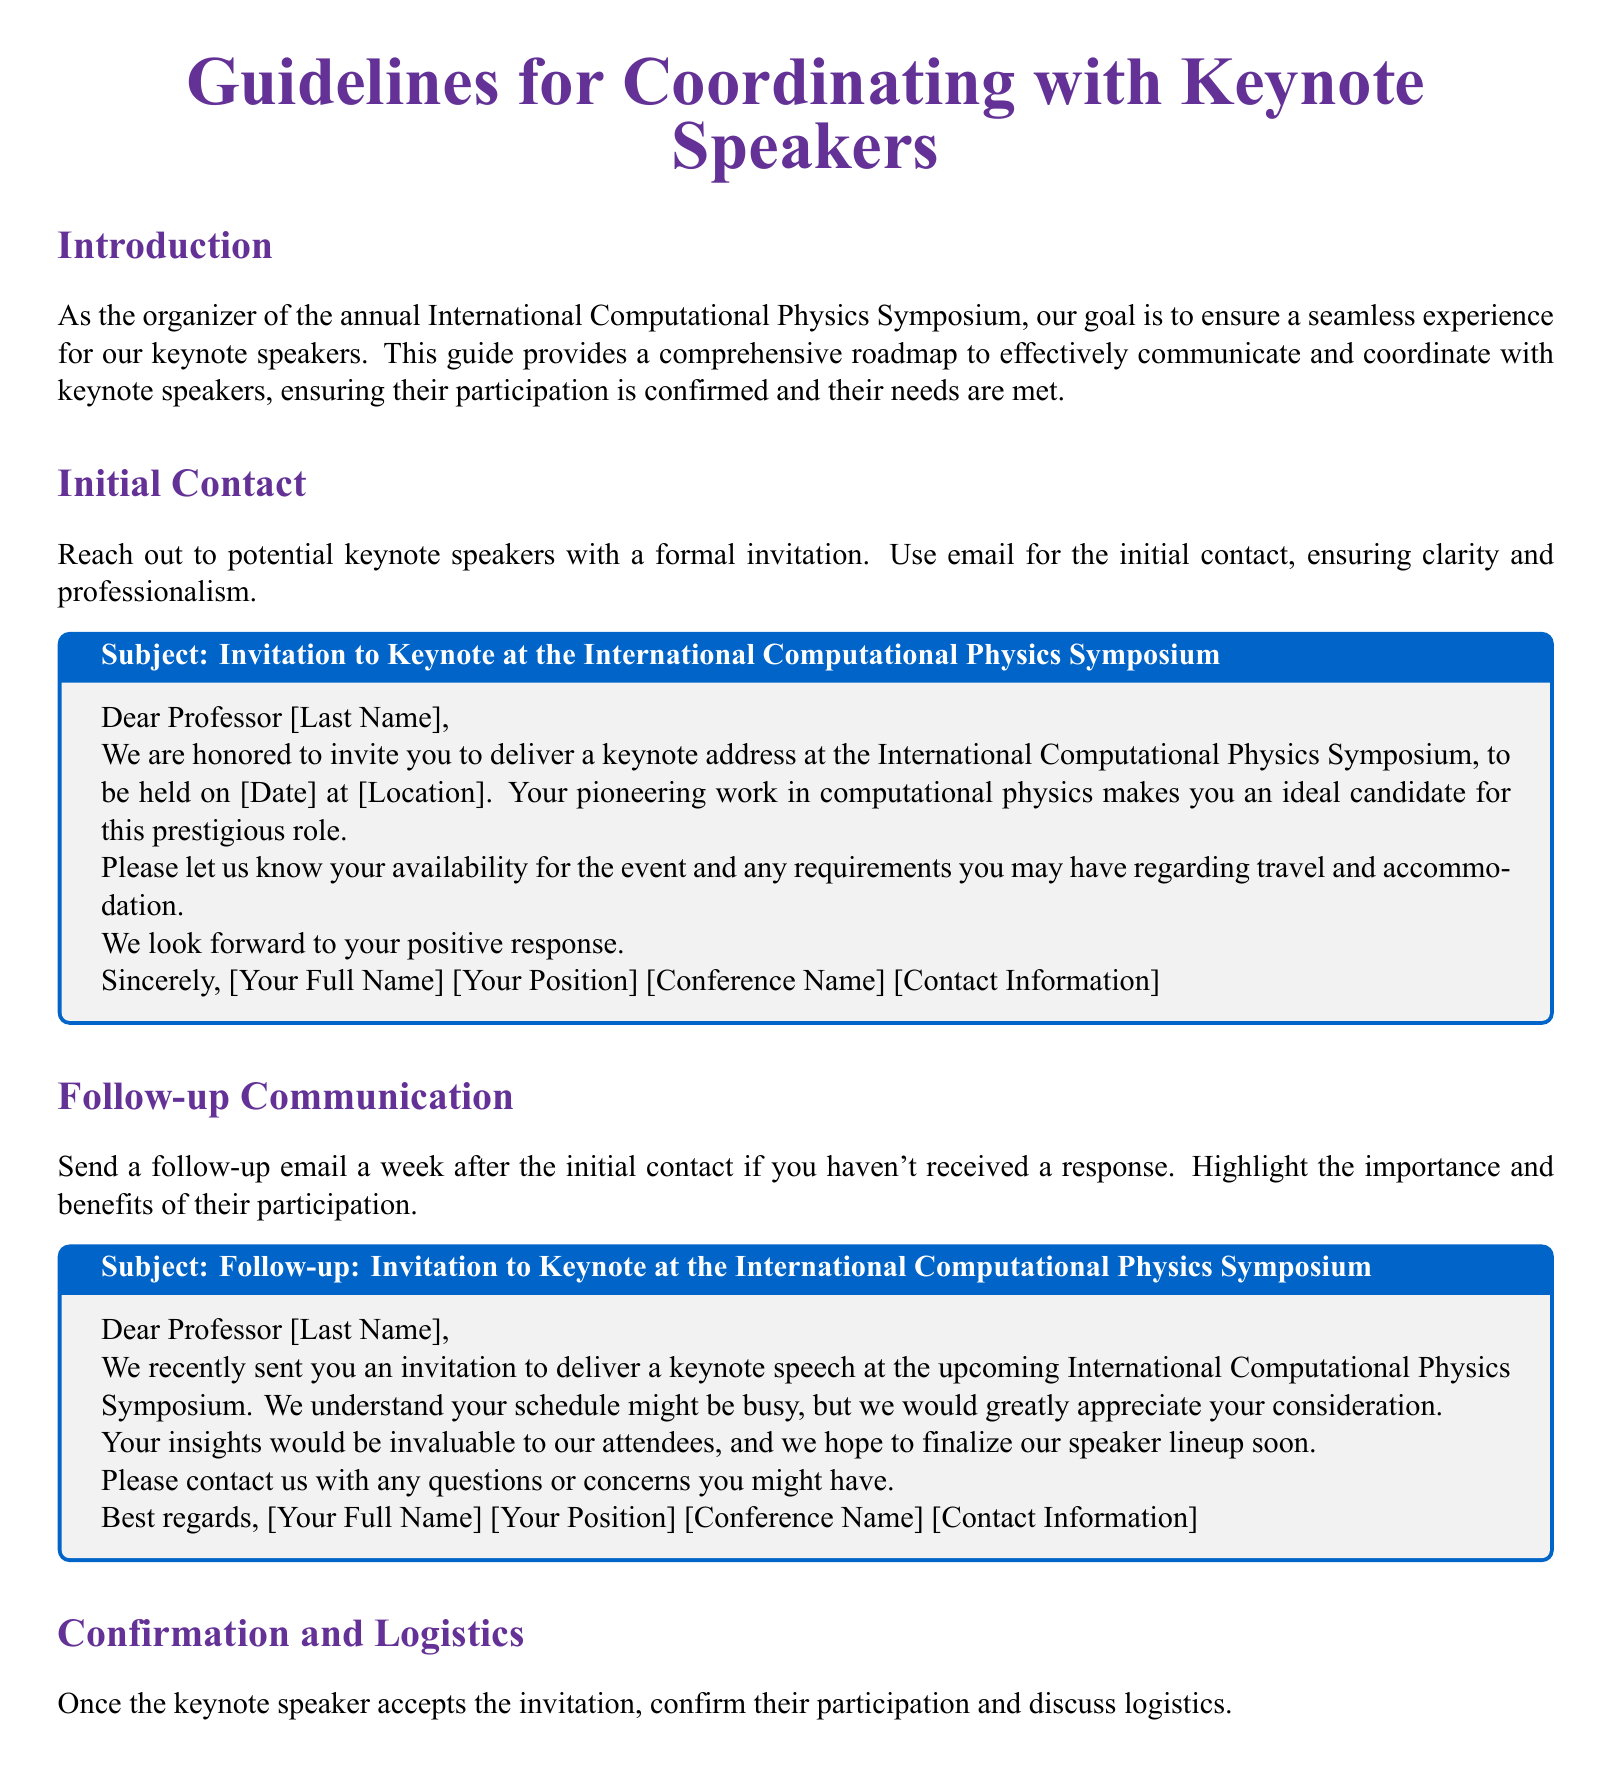What is the title of the document? The title appears on the cover page of the document and indicates the main focus of the content.
Answer: Guidelines for Coordinating with Keynote Speakers What is the name of the symposium mentioned in the document? The name of the symposium is included in the invitation template and is crucial for context.
Answer: International Computational Physics Symposium What should be included in the follow-up email subject line? The subject line is specified in the email template for follow-up communication.
Answer: Follow-up: Invitation to Keynote at the International Computational Physics Symposium What must a keynote speaker provide upon confirmation of participation? This information is requested in the confirmation email to confirm arrangements with the keynote speaker.
Answer: Preferred travel dates and times How soon should a follow-up email be sent after the initial contact? This detail outlines the expected timeline for communication surrounding the invitation.
Answer: One week Which color is used for section titles in the document? The color used for section titles is specified within the formatting details of the document.
Answer: physicspurple What is the purpose of the final preparation email? The purpose is outlined in the section discussing pre-event coordination and reinforces the need for updates.
Answer: To provide final updates and confirm arrangements How should the initial contact invitation be sent? This detail indicates the method of communication to initiate contact with potential keynote speakers.
Answer: Email What is emphasized in the follow-up communication? The follow-up email outlines the rationale for the importance of the keynote speaker’s participation.
Answer: Importance and benefits of their participation 